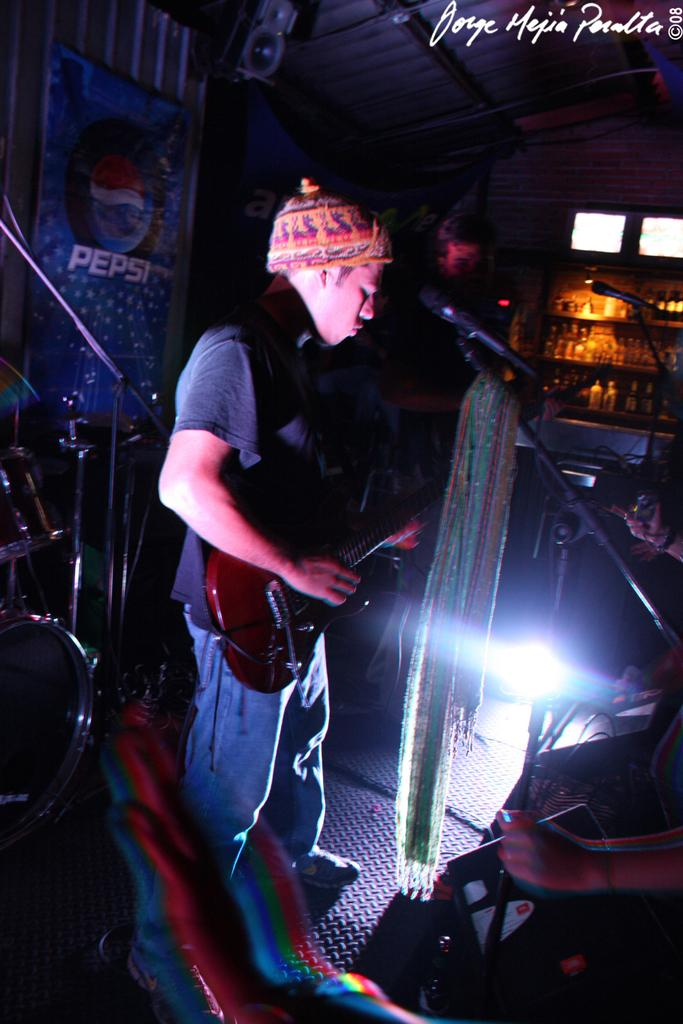What is the main subject of the image? The main subject of the image is a man. What is the man doing in the image? The man is standing and playing the guitar. What is the man wearing on his head? The man is wearing a cap. What is the man wearing on his upper body? The man is wearing a t-shirt. What object can be seen on the right side of the image? There is a microphone on the right side of the image. What type of chicken is sitting on the man's shoulder in the image? There is no chicken present in the image. What kind of guide is the man holding in the image? There is no guide present in the image; the man is playing the guitar. 